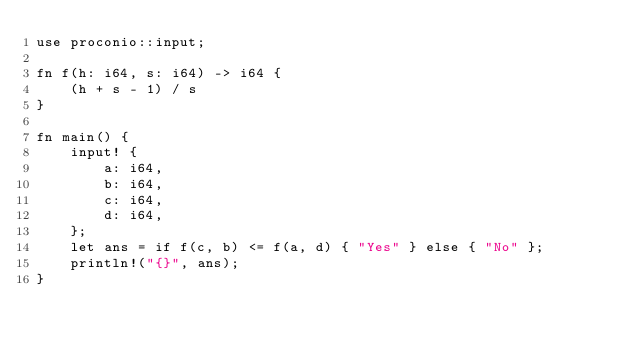Convert code to text. <code><loc_0><loc_0><loc_500><loc_500><_Rust_>use proconio::input;

fn f(h: i64, s: i64) -> i64 {
    (h + s - 1) / s
}

fn main() {
    input! {
        a: i64,
        b: i64,
        c: i64,
        d: i64,
    };
    let ans = if f(c, b) <= f(a, d) { "Yes" } else { "No" };
    println!("{}", ans);
}
</code> 